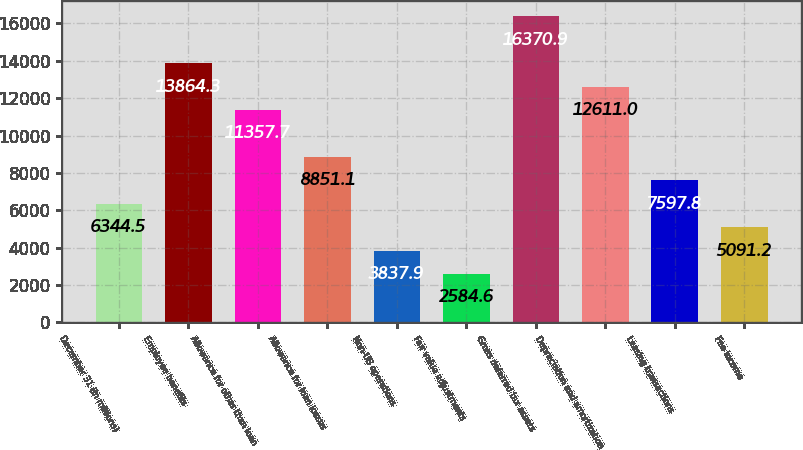Convert chart to OTSL. <chart><loc_0><loc_0><loc_500><loc_500><bar_chart><fcel>December 31 (in millions)<fcel>Employee benefits<fcel>Allowance for other than loan<fcel>Allowance for loan losses<fcel>Non-US operations<fcel>Fair value adjustments<fcel>Gross deferred tax assets<fcel>Depreciation and amortization<fcel>Leasing transactions<fcel>Fee income<nl><fcel>6344.5<fcel>13864.3<fcel>11357.7<fcel>8851.1<fcel>3837.9<fcel>2584.6<fcel>16370.9<fcel>12611<fcel>7597.8<fcel>5091.2<nl></chart> 